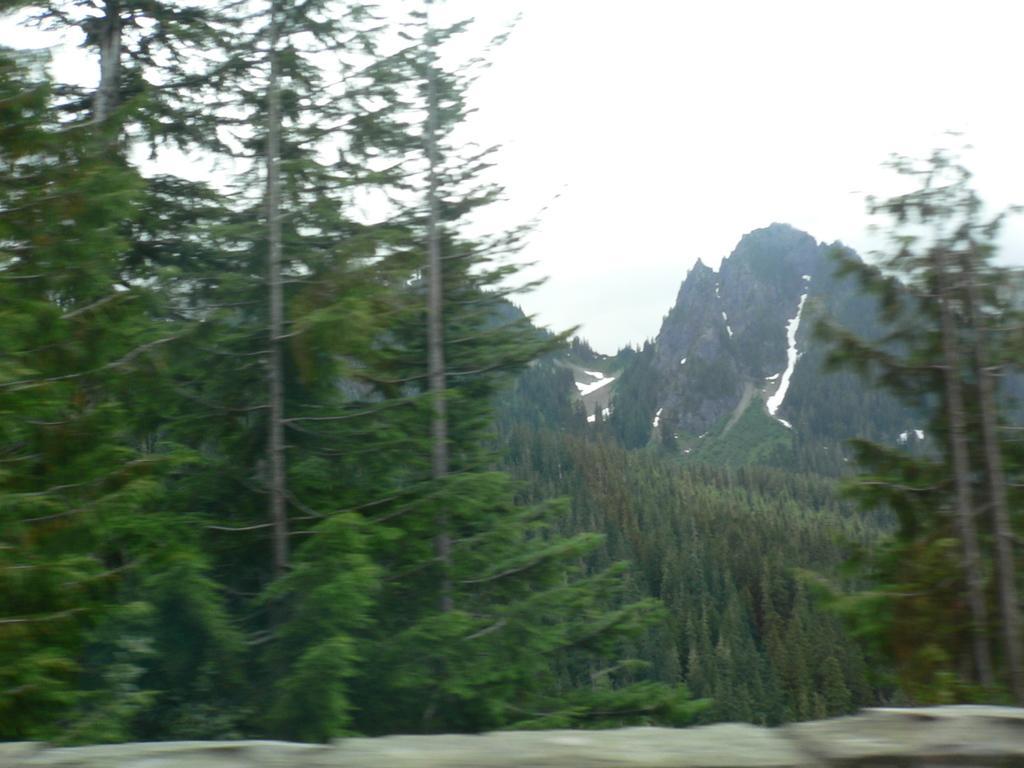Can you describe this image briefly? In this picture we can observe some trees. In the background there are hills and a sky. 